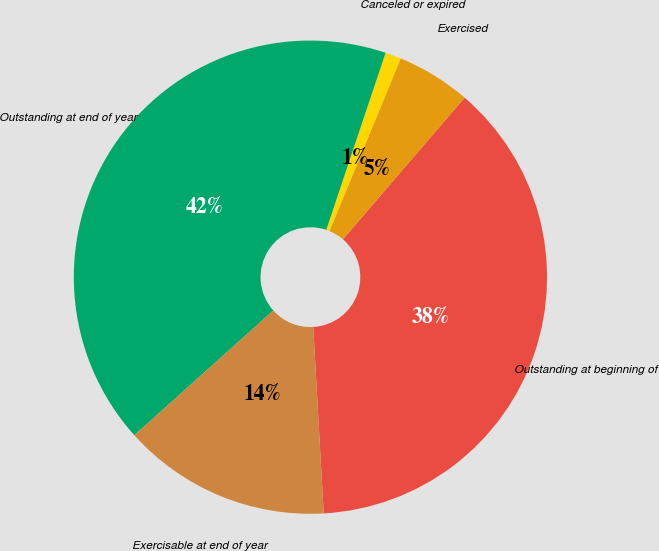Convert chart to OTSL. <chart><loc_0><loc_0><loc_500><loc_500><pie_chart><fcel>Outstanding at beginning of<fcel>Exercised<fcel>Canceled or expired<fcel>Outstanding at end of year<fcel>Exercisable at end of year<nl><fcel>37.81%<fcel>5.06%<fcel>1.09%<fcel>41.78%<fcel>14.25%<nl></chart> 